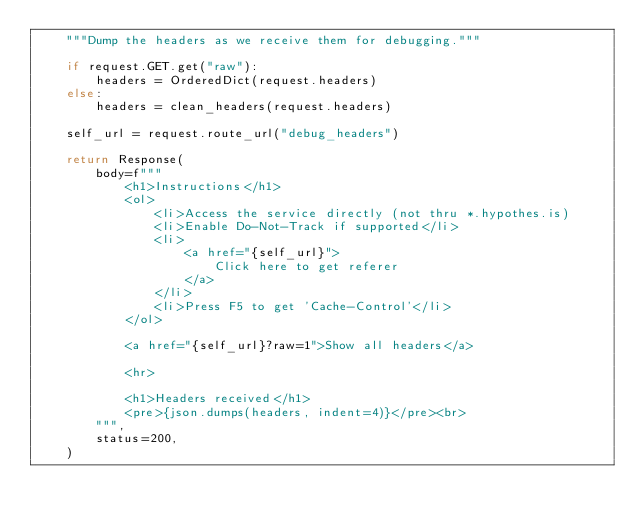Convert code to text. <code><loc_0><loc_0><loc_500><loc_500><_Python_>    """Dump the headers as we receive them for debugging."""

    if request.GET.get("raw"):
        headers = OrderedDict(request.headers)
    else:
        headers = clean_headers(request.headers)

    self_url = request.route_url("debug_headers")

    return Response(
        body=f"""
            <h1>Instructions</h1>
            <ol>
                <li>Access the service directly (not thru *.hypothes.is)
                <li>Enable Do-Not-Track if supported</li>
                <li>
                    <a href="{self_url}">
                        Click here to get referer
                    </a>
                </li>
                <li>Press F5 to get 'Cache-Control'</li>
            </ol>

            <a href="{self_url}?raw=1">Show all headers</a>

            <hr>

            <h1>Headers received</h1>
            <pre>{json.dumps(headers, indent=4)}</pre><br>
        """,
        status=200,
    )
</code> 